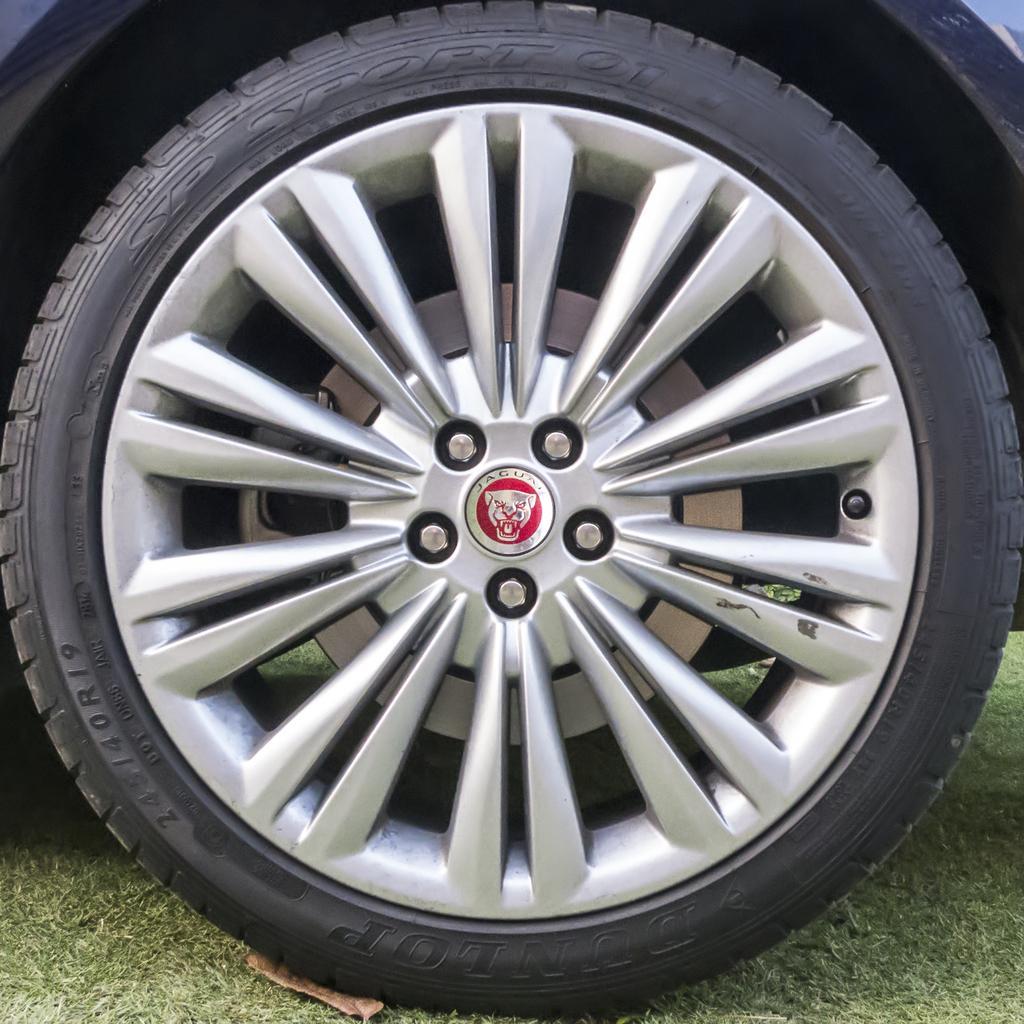Describe this image in one or two sentences. In the picture there is a wheel of a vehicle and under the wheel there is a grass surface. 